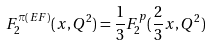Convert formula to latex. <formula><loc_0><loc_0><loc_500><loc_500>F _ { 2 } ^ { \pi ( E F ) } ( x , Q ^ { 2 } ) = \frac { 1 } { 3 } F _ { 2 } ^ { p } ( \frac { 2 } { 3 } x , Q ^ { 2 } )</formula> 